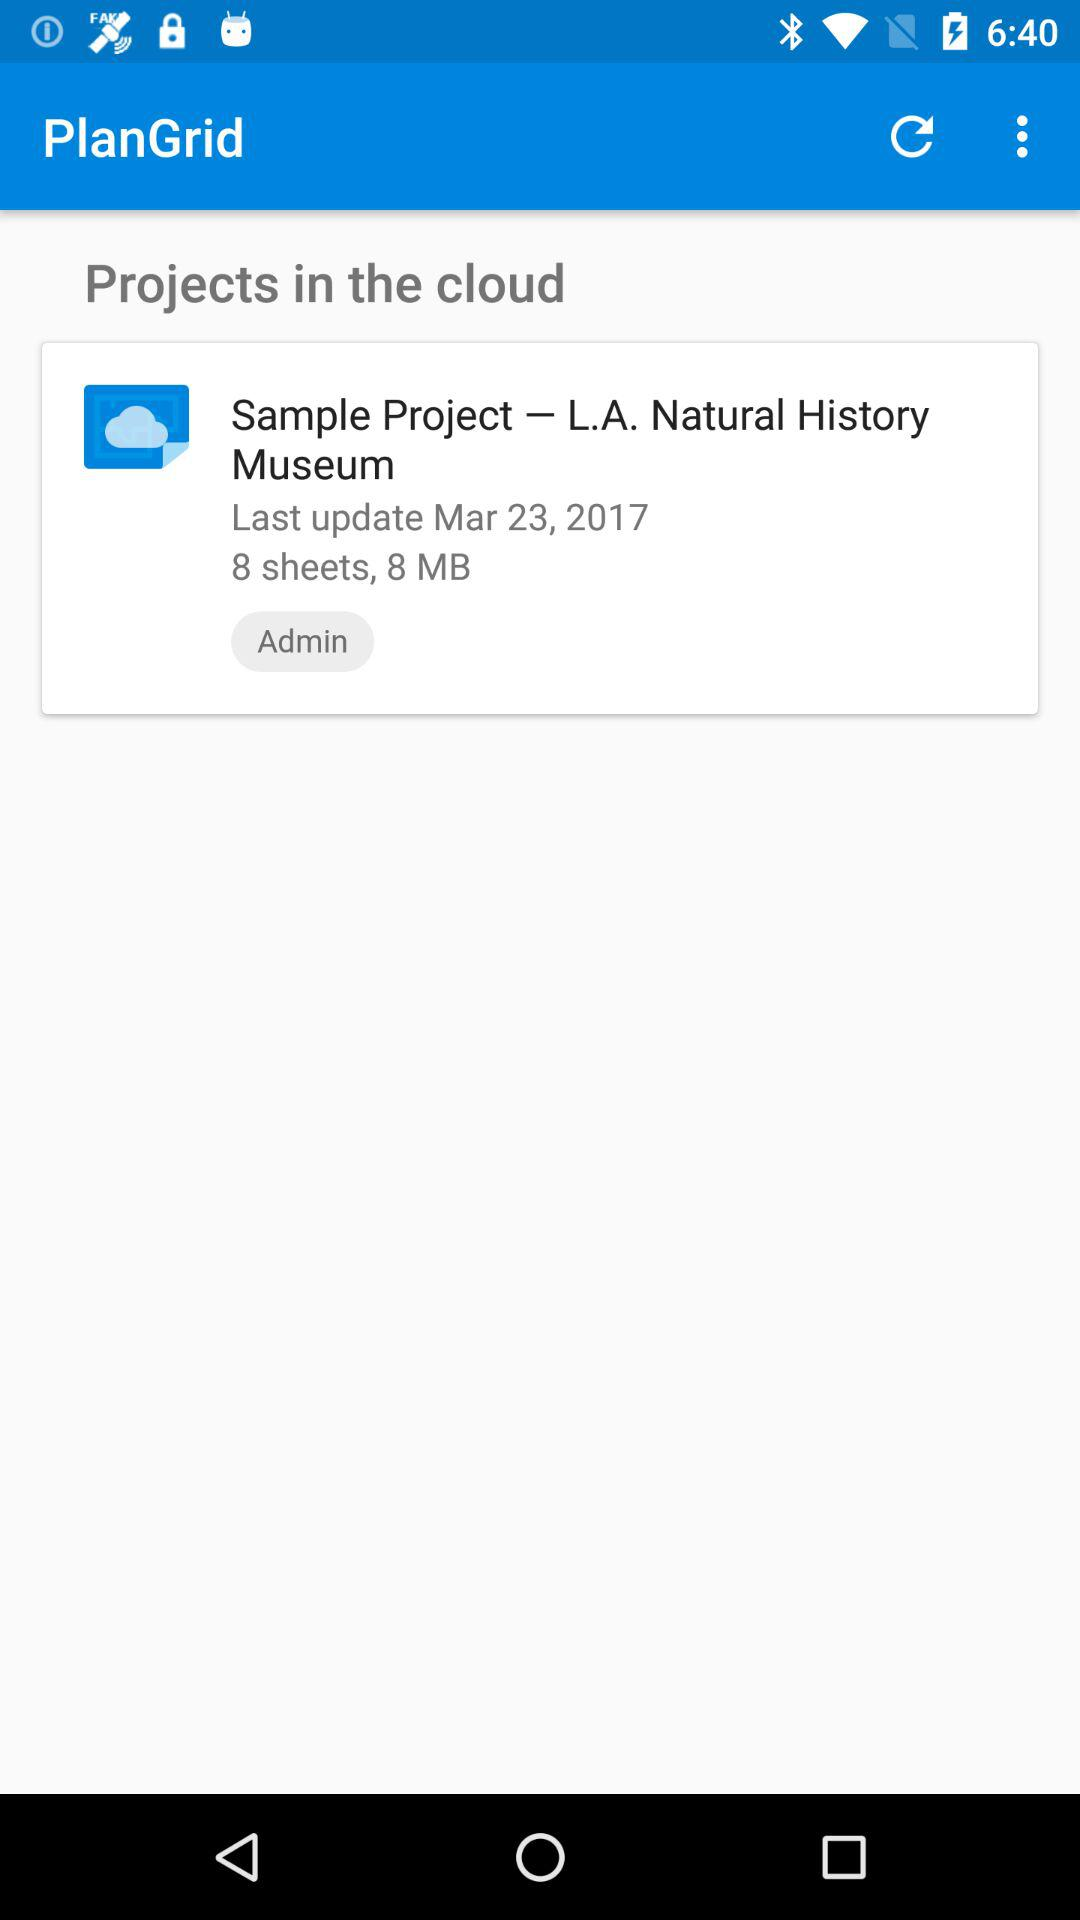When was the sample project last updated? The sample project was last updated on March 23, 2017. 